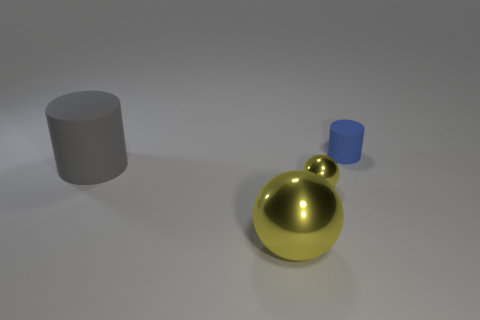What size is the thing that is left of the tiny yellow sphere and behind the large shiny thing?
Give a very brief answer. Large. What is the color of the other ball that is made of the same material as the large yellow ball?
Make the answer very short. Yellow. How many yellow things have the same material as the big cylinder?
Provide a succinct answer. 0. Are there the same number of big gray rubber objects behind the big rubber thing and small blue objects left of the blue rubber thing?
Provide a short and direct response. Yes. Do the large shiny object and the blue object right of the large gray rubber thing have the same shape?
Make the answer very short. No. There is a object that is the same color as the big sphere; what is it made of?
Offer a very short reply. Metal. Is there any other thing that is the same shape as the small blue object?
Ensure brevity in your answer.  Yes. Do the blue cylinder and the small thing to the left of the blue cylinder have the same material?
Offer a terse response. No. What is the color of the large thing that is right of the rubber object in front of the matte cylinder right of the big gray cylinder?
Your answer should be compact. Yellow. Is there anything else that has the same size as the blue cylinder?
Your response must be concise. Yes. 